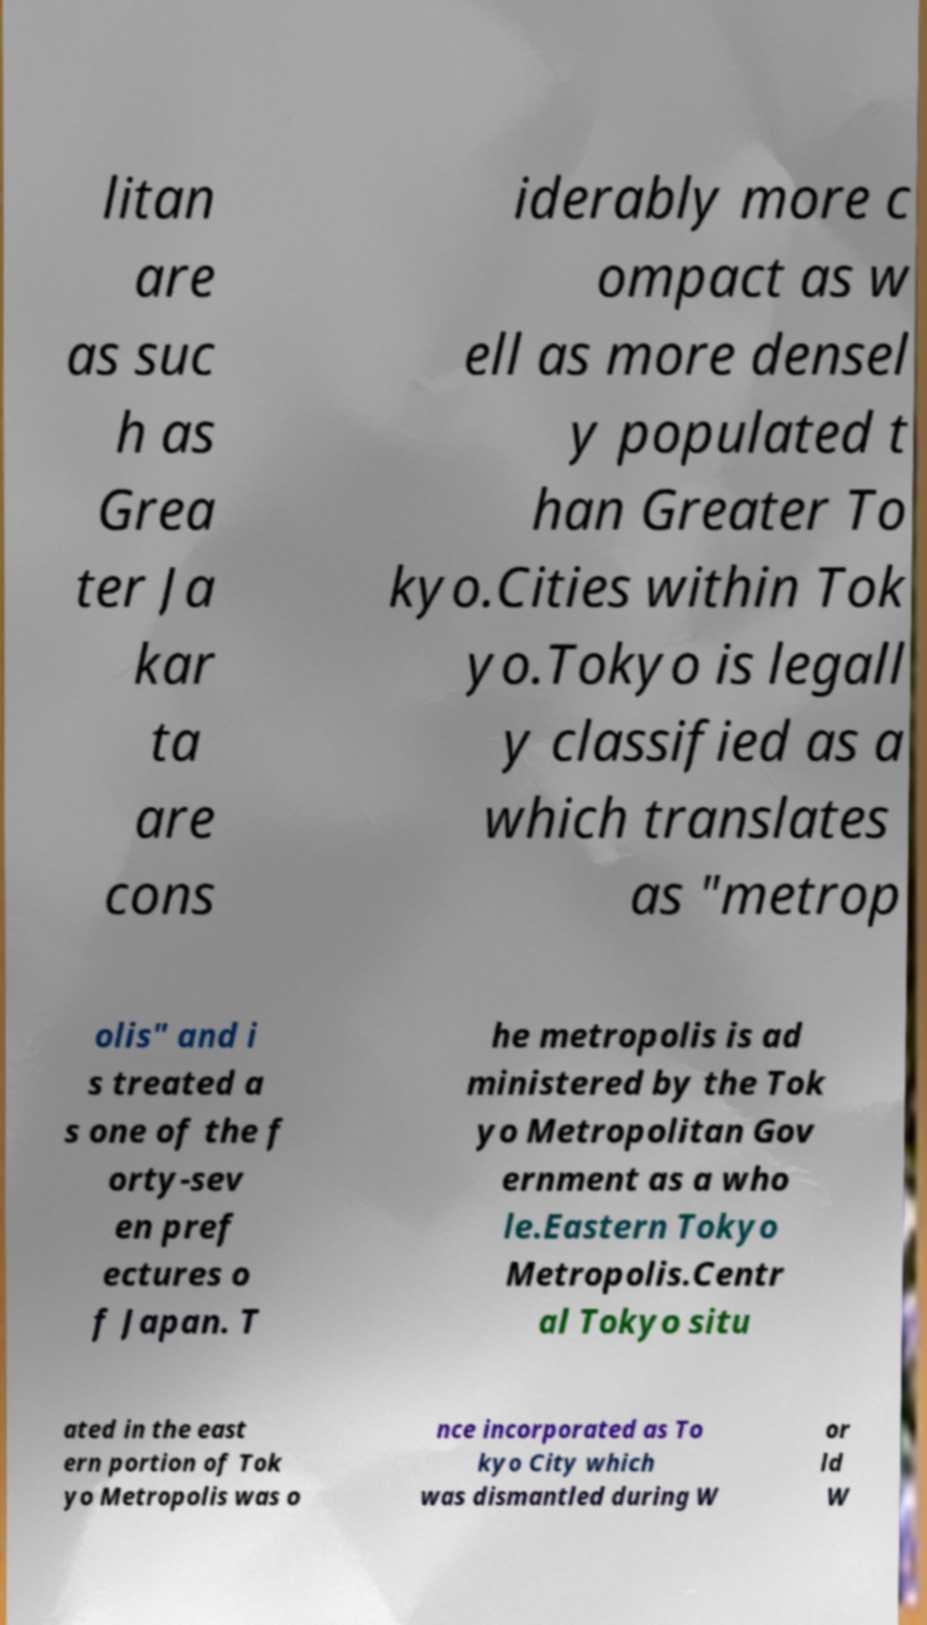There's text embedded in this image that I need extracted. Can you transcribe it verbatim? litan are as suc h as Grea ter Ja kar ta are cons iderably more c ompact as w ell as more densel y populated t han Greater To kyo.Cities within Tok yo.Tokyo is legall y classified as a which translates as "metrop olis" and i s treated a s one of the f orty-sev en pref ectures o f Japan. T he metropolis is ad ministered by the Tok yo Metropolitan Gov ernment as a who le.Eastern Tokyo Metropolis.Centr al Tokyo situ ated in the east ern portion of Tok yo Metropolis was o nce incorporated as To kyo City which was dismantled during W or ld W 